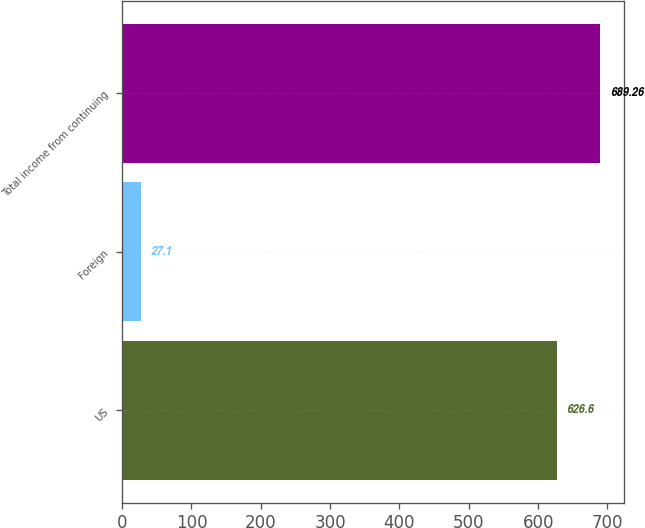Convert chart to OTSL. <chart><loc_0><loc_0><loc_500><loc_500><bar_chart><fcel>US<fcel>Foreign<fcel>Total income from continuing<nl><fcel>626.6<fcel>27.1<fcel>689.26<nl></chart> 